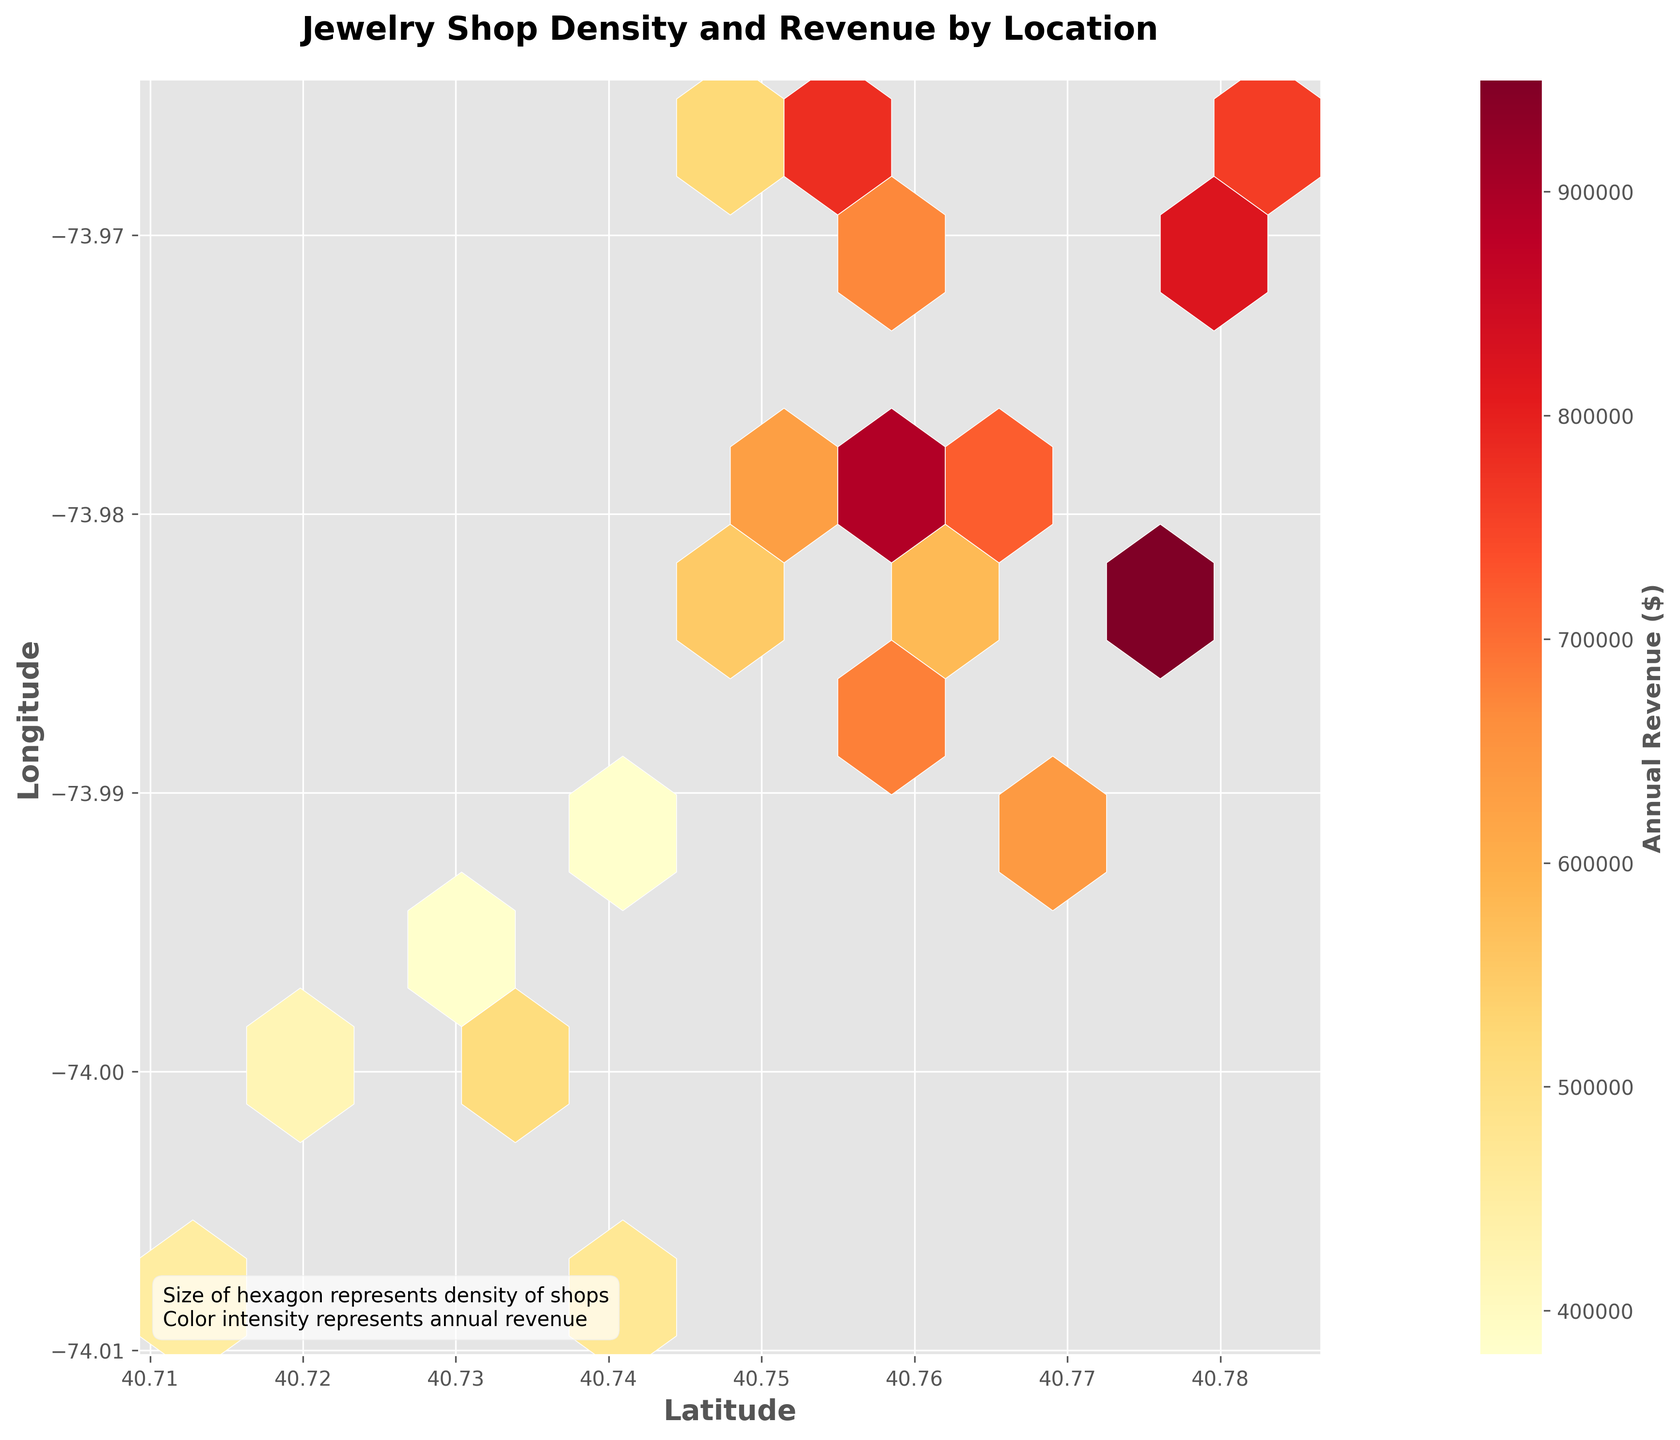What is the title of the figure? The title of the figure is usually displayed prominently at the top to give a quick indication of what the plot represents. Here, it is labeled as 'Jewelry Shop Density and Revenue by Location'.
Answer: 'Jewelry Shop Density and Revenue by Location' What do the axes represent? The labels on the axes are used to indicate what variables are being plotted. The x-axis represents 'Latitude', and the y-axis represents 'Longitude'.
Answer: 'Latitude' and 'Longitude' How does the color intensity relate to annual revenue? The figure includes a color bar labeled 'Annual Revenue ($)' which suggests that darker colors represent higher annual revenues. The annotation also mentions that color intensity represents annual revenue.
Answer: Darker colors indicate higher annual revenue Which location has the highest density of jewelry shops? The hexagon with the highest density of jewelry shops is indicated by the largest hexagon. Observing the hexagons, the one centered near (40.7739, -73.9837) appears largest, suggesting it has the highest shop density.
Answer: Near (40.7739, -73.9837) What is the annual revenue and density of the most northern location? The most northern point on the latitudinal axis corresponds to the highest annual revenue value on the color bar. The most northern point is near (40.7739, -73.9837) with a density of 17 and an annual revenue of $950000.
Answer: $950000 and density 17 Is there a general trend between the density of jewelry shops and their annual revenue? Observing the color intensity within hexagons across various densities, there is a noticeable pattern that denser areas (larger hexagons) tend to have hexagons with darker colors, suggesting higher revenues.
Answer: Higher density areas tend to have higher annual revenues Which location has the lowest annual revenue? The hexagon with the lightest color will represent the lowest annual revenue. The lightest hexagon is near (40.7282, -73.9942), with an annual revenue of $350000.
Answer: Near (40.7282, -73.9942) with $350000 How is the annual revenue distributed across different latitudes? Observing the color distribution of hexagons along the latitude axis, the annual revenue varies but generally increases from lighter to darker shades towards the northern locations with some exceptions.
Answer: Generally increases northward Are there any outliers in terms of annual revenue? Outliers can be identified by looking for unusually light or dark hexagons. The hexagon near (40.7739, -73.9837) is significantly darker, suggesting an outlier with exceptionally high annual revenue.
Answer: Near (40.7739, -73.9837) with $950000 